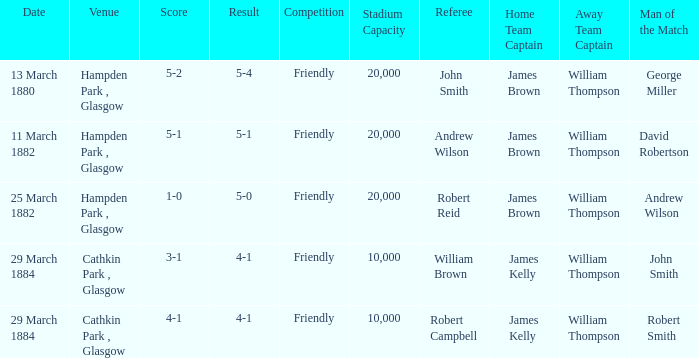Which item resulted in a score of 4-1? 3-1, 4-1. Write the full table. {'header': ['Date', 'Venue', 'Score', 'Result', 'Competition', 'Stadium Capacity', 'Referee', 'Home Team Captain', 'Away Team Captain', 'Man of the Match'], 'rows': [['13 March 1880', 'Hampden Park , Glasgow', '5-2', '5-4', 'Friendly', '20,000', 'John Smith', 'James Brown', 'William Thompson', 'George Miller'], ['11 March 1882', 'Hampden Park , Glasgow', '5-1', '5-1', 'Friendly', '20,000', 'Andrew Wilson', 'James Brown', 'William Thompson', 'David Robertson'], ['25 March 1882', 'Hampden Park , Glasgow', '1-0', '5-0', 'Friendly', '20,000', 'Robert Reid', 'James Brown', 'William Thompson', 'Andrew Wilson'], ['29 March 1884', 'Cathkin Park , Glasgow', '3-1', '4-1', 'Friendly', '10,000', 'William Brown', 'James Kelly', 'William Thompson', 'John Smith'], ['29 March 1884', 'Cathkin Park , Glasgow', '4-1', '4-1', 'Friendly', '10,000', 'Robert Campbell', 'James Kelly', 'William Thompson', 'Robert Smith']]} 